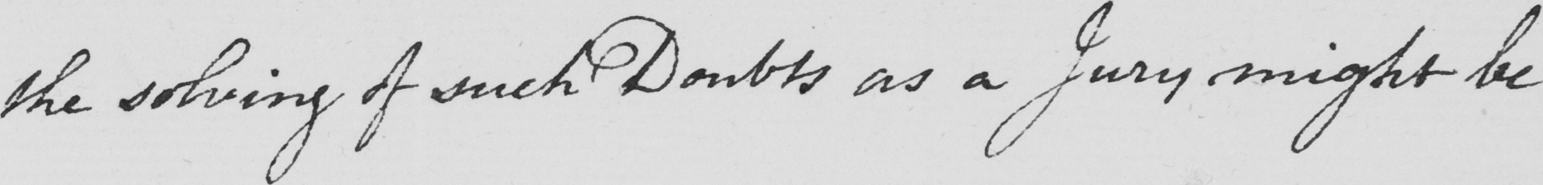What is written in this line of handwriting? the solving of such Doubts as a Jury might be 